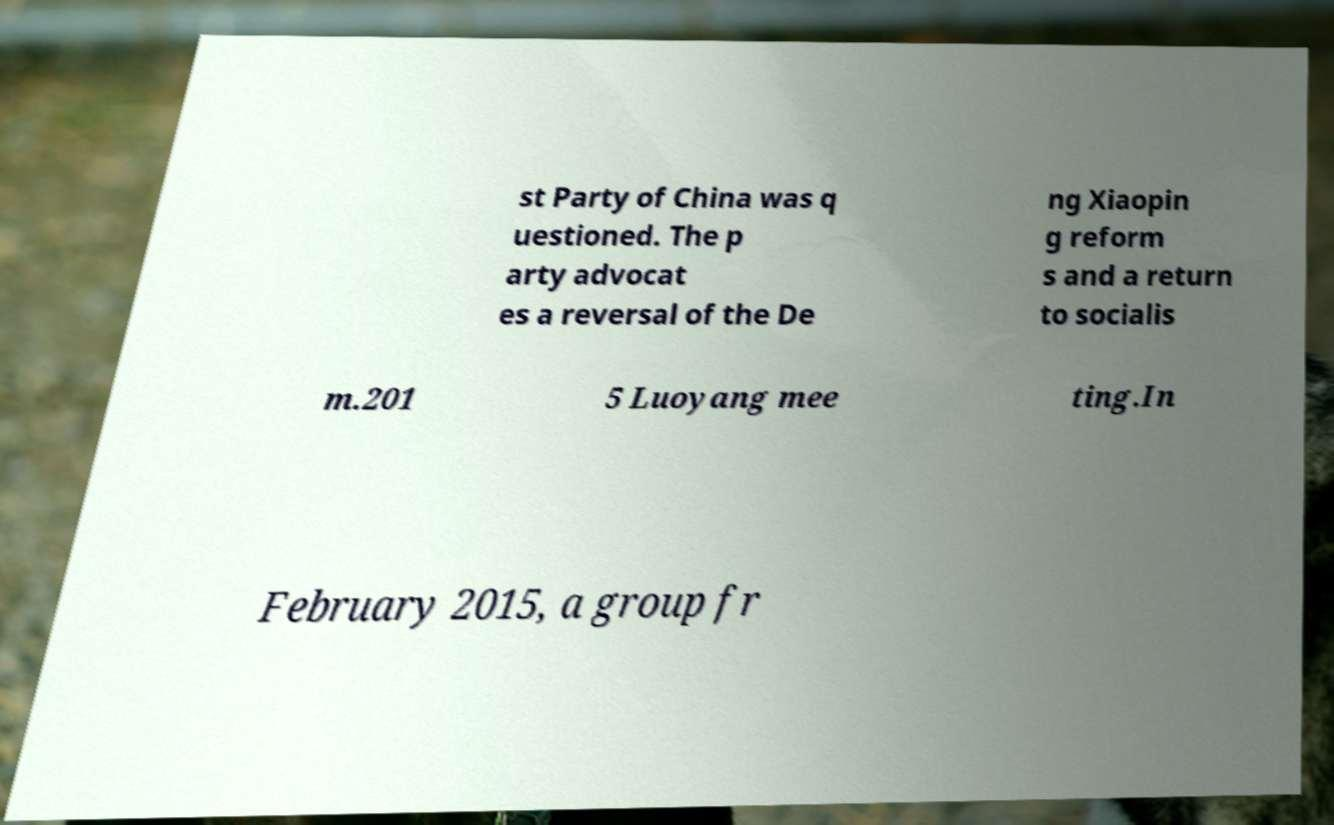Please read and relay the text visible in this image. What does it say? st Party of China was q uestioned. The p arty advocat es a reversal of the De ng Xiaopin g reform s and a return to socialis m.201 5 Luoyang mee ting.In February 2015, a group fr 